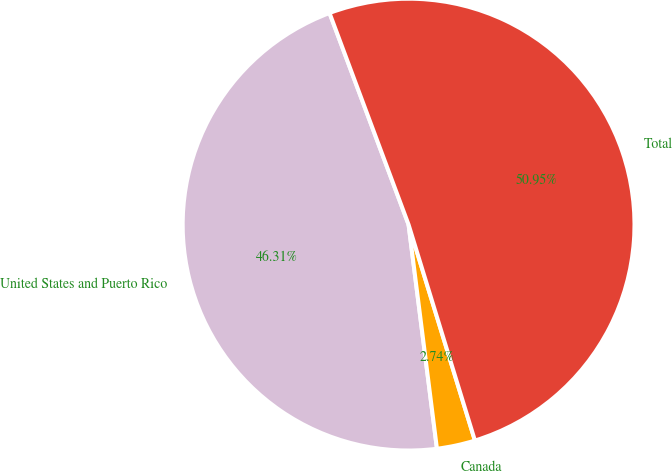Convert chart. <chart><loc_0><loc_0><loc_500><loc_500><pie_chart><fcel>United States and Puerto Rico<fcel>Canada<fcel>Total<nl><fcel>46.31%<fcel>2.74%<fcel>50.94%<nl></chart> 